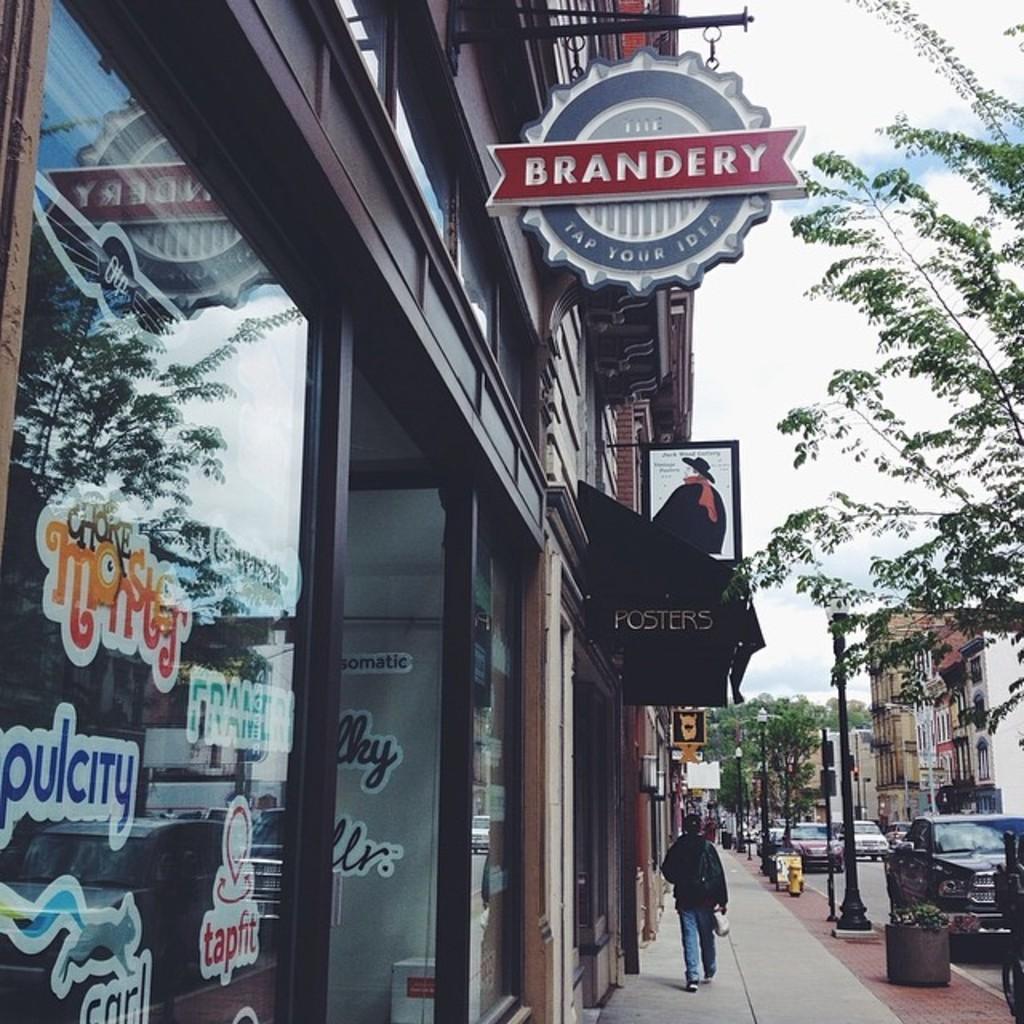Can you describe this image briefly? In the picture we can see a building with a shop and glass to it and near the building we can see a path with some person walking on it and beside him we can see a pole and a car parked near the path and on the opposite side, we can see some buildings and some cars parked near it and in the background we can see some trees, and sky. 